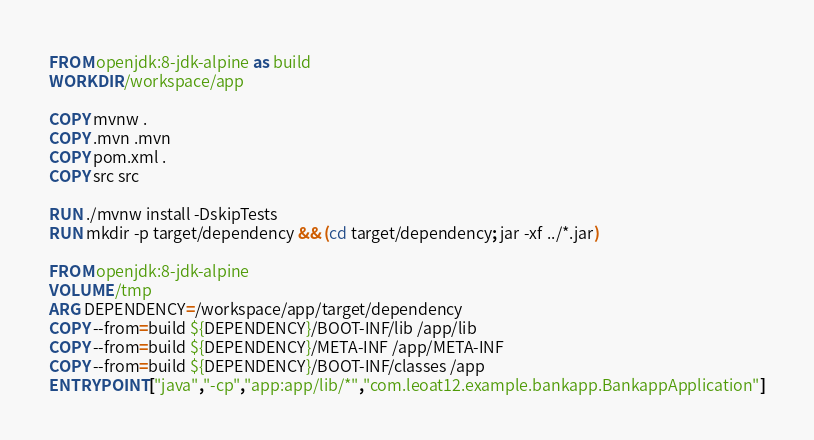<code> <loc_0><loc_0><loc_500><loc_500><_Dockerfile_>FROM openjdk:8-jdk-alpine as build
WORKDIR /workspace/app

COPY mvnw .
COPY .mvn .mvn
COPY pom.xml .
COPY src src

RUN ./mvnw install -DskipTests
RUN mkdir -p target/dependency && (cd target/dependency; jar -xf ../*.jar)

FROM openjdk:8-jdk-alpine
VOLUME /tmp
ARG DEPENDENCY=/workspace/app/target/dependency
COPY --from=build ${DEPENDENCY}/BOOT-INF/lib /app/lib
COPY --from=build ${DEPENDENCY}/META-INF /app/META-INF
COPY --from=build ${DEPENDENCY}/BOOT-INF/classes /app
ENTRYPOINT ["java","-cp","app:app/lib/*","com.leoat12.example.bankapp.BankappApplication"]</code> 